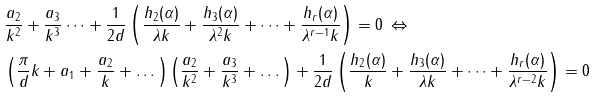Convert formula to latex. <formula><loc_0><loc_0><loc_500><loc_500>& \frac { a _ { 2 } } { k ^ { 2 } } + \frac { a _ { 3 } } { k ^ { 3 } } \dots + \frac { 1 } { 2 d } \left ( \frac { h _ { 2 } ( \alpha ) } { \lambda k } + \frac { h _ { 3 } ( \alpha ) } { \lambda ^ { 2 } k } + \dots + \frac { h _ { r } ( \alpha ) } { \lambda ^ { r - 1 } k } \right ) = 0 \, \Leftrightarrow \\ & \left ( \frac { \pi } { d } k + a _ { 1 } + \frac { a _ { 2 } } { k } + \dots \right ) \left ( \frac { a _ { 2 } } { k ^ { 2 } } + \frac { a _ { 3 } } { k ^ { 3 } } + \dots \right ) + \frac { 1 } { 2 d } \left ( \frac { h _ { 2 } ( \alpha ) } { k } + \frac { h _ { 3 } ( \alpha ) } { \lambda k } + \dots + \frac { h _ { r } ( \alpha ) } { \lambda ^ { r - 2 } k } \right ) = 0</formula> 